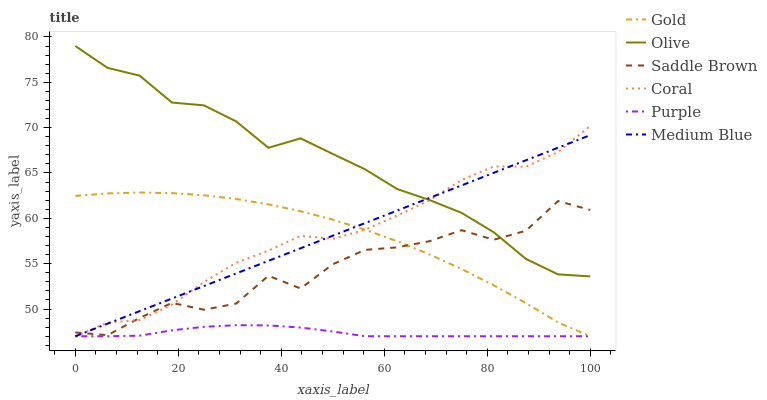Does Purple have the minimum area under the curve?
Answer yes or no. Yes. Does Olive have the maximum area under the curve?
Answer yes or no. Yes. Does Coral have the minimum area under the curve?
Answer yes or no. No. Does Coral have the maximum area under the curve?
Answer yes or no. No. Is Medium Blue the smoothest?
Answer yes or no. Yes. Is Saddle Brown the roughest?
Answer yes or no. Yes. Is Purple the smoothest?
Answer yes or no. No. Is Purple the roughest?
Answer yes or no. No. Does Gold have the lowest value?
Answer yes or no. Yes. Does Olive have the lowest value?
Answer yes or no. No. Does Olive have the highest value?
Answer yes or no. Yes. Does Coral have the highest value?
Answer yes or no. No. Is Purple less than Saddle Brown?
Answer yes or no. Yes. Is Olive greater than Purple?
Answer yes or no. Yes. Does Gold intersect Medium Blue?
Answer yes or no. Yes. Is Gold less than Medium Blue?
Answer yes or no. No. Is Gold greater than Medium Blue?
Answer yes or no. No. Does Purple intersect Saddle Brown?
Answer yes or no. No. 